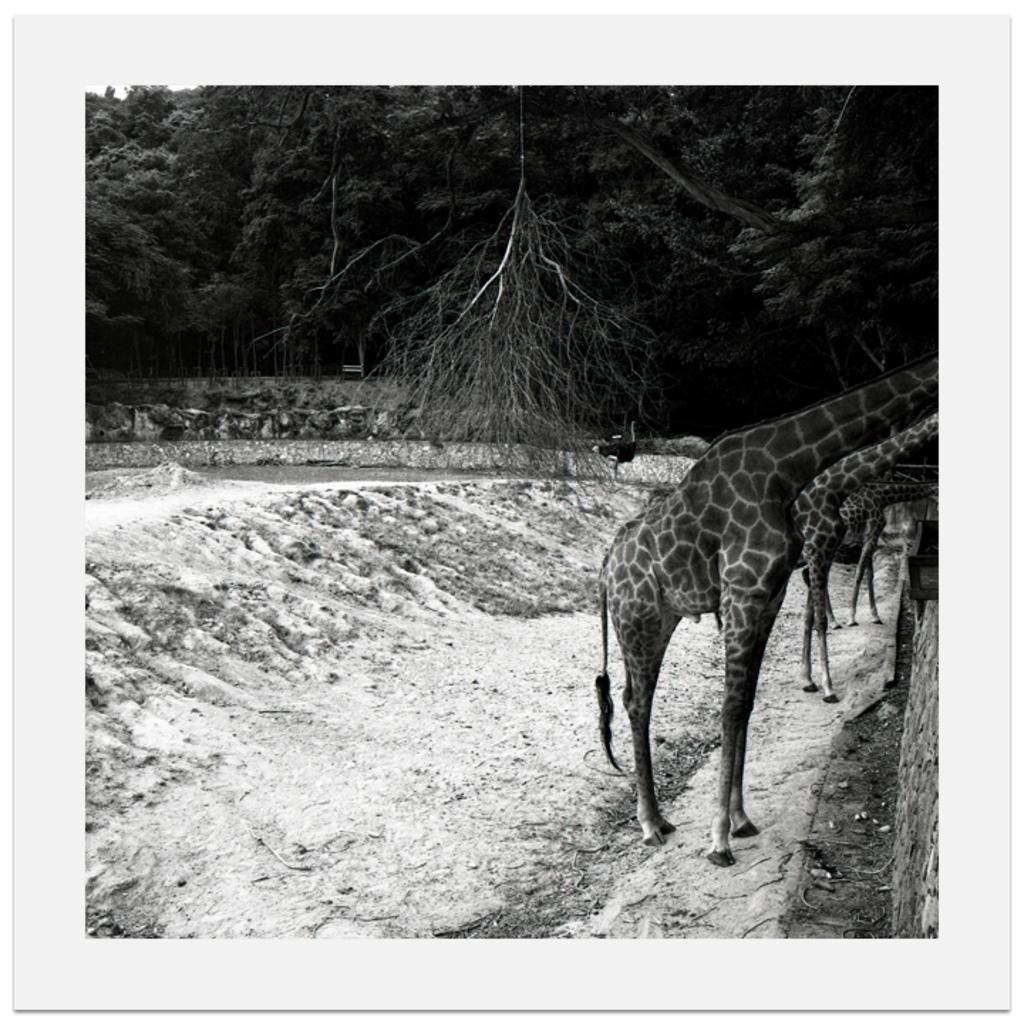In one or two sentences, can you explain what this image depicts? This is a black and white picture. In this picture we can see a few giraffes on the right side. There are some trees visible in the background. 